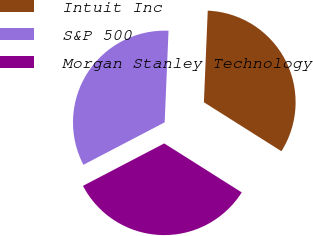Convert chart to OTSL. <chart><loc_0><loc_0><loc_500><loc_500><pie_chart><fcel>Intuit Inc<fcel>S&P 500<fcel>Morgan Stanley Technology<nl><fcel>33.3%<fcel>33.33%<fcel>33.37%<nl></chart> 